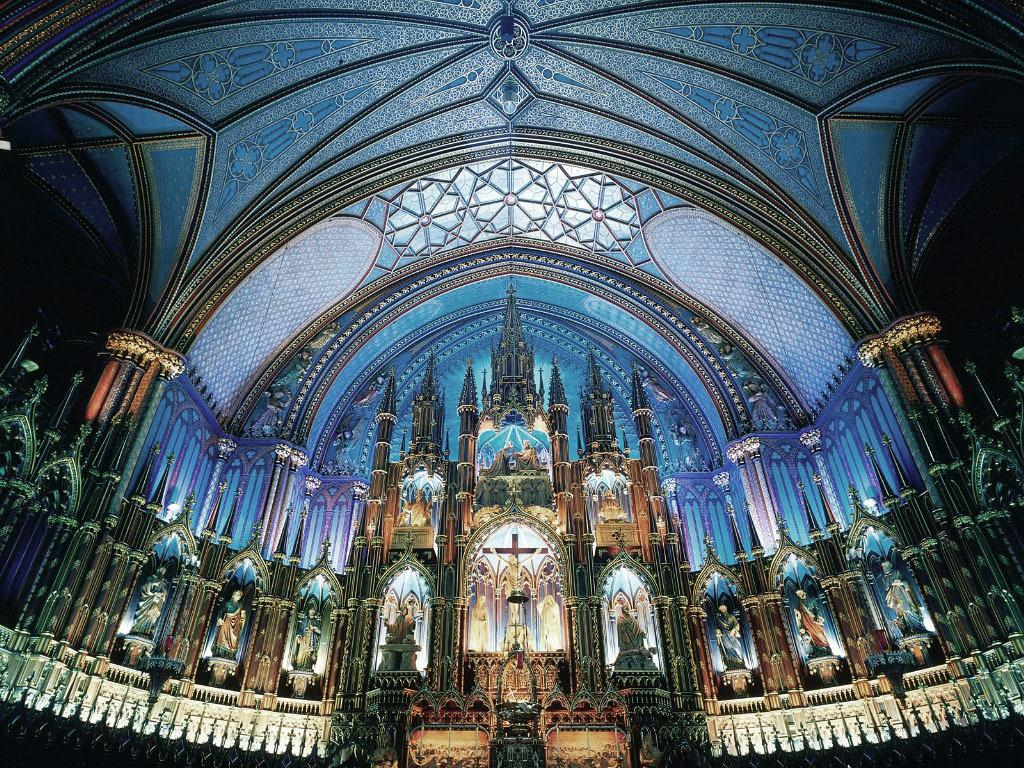What type of location is depicted in the image? The image shows an inner view of a building. What decorative elements can be seen in the image? There are statues visible in the image. What architectural feature is present in the image? There is a designer ceiling in the image. Can you describe the spark coming from the girl's hand in the image? There is no girl or spark present in the image; it only shows an inner view of a building with statues and a designer ceiling. 